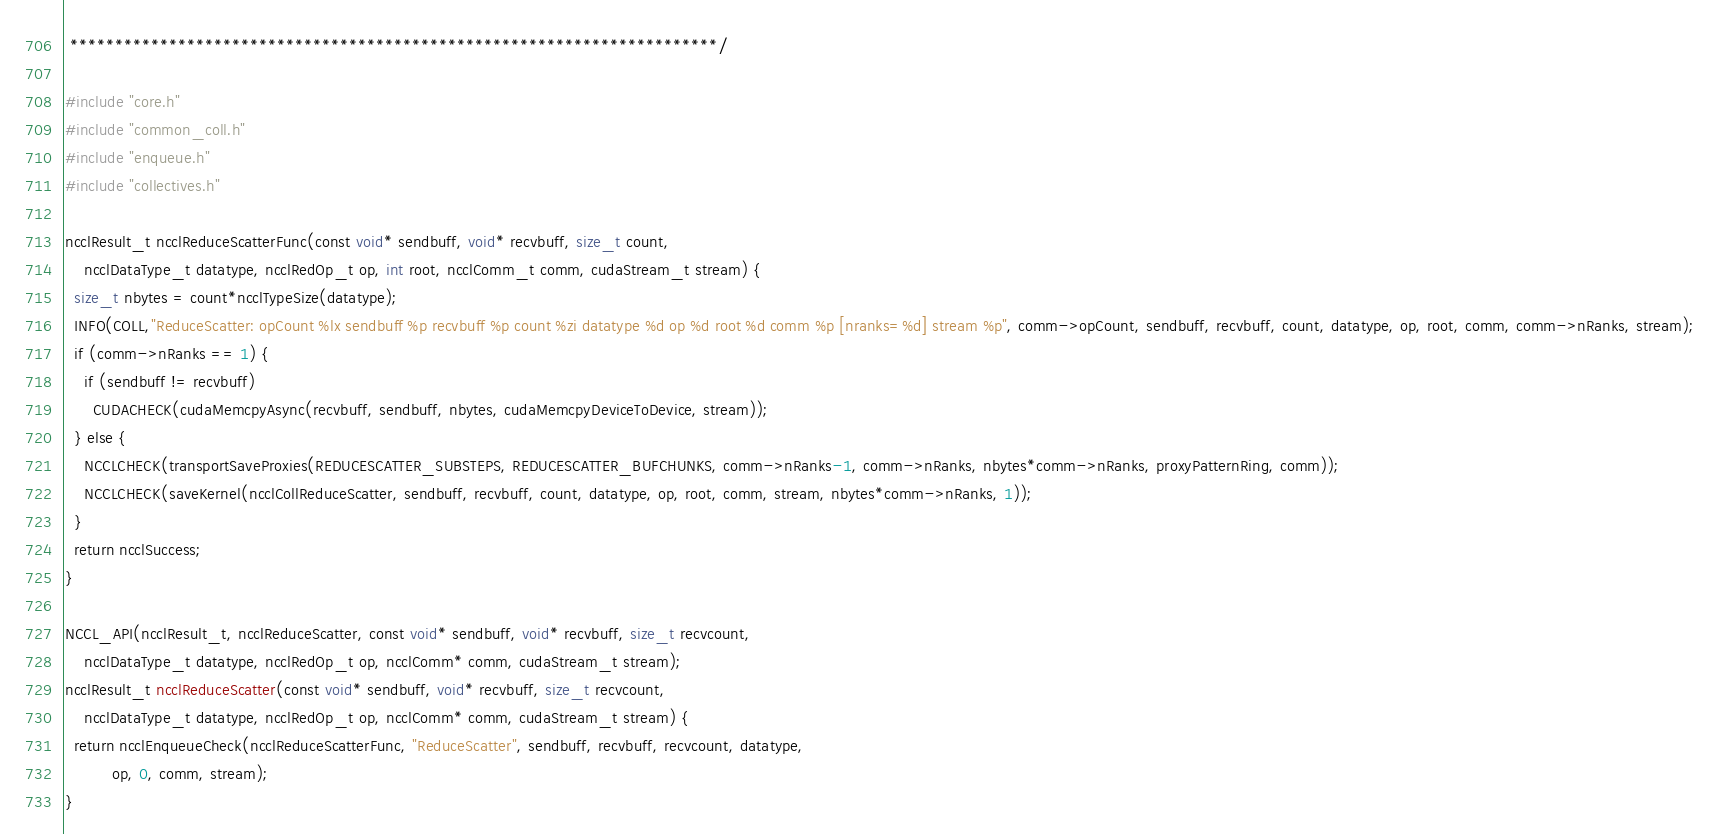<code> <loc_0><loc_0><loc_500><loc_500><_Cuda_> ************************************************************************/

#include "core.h"
#include "common_coll.h"
#include "enqueue.h"
#include "collectives.h"

ncclResult_t ncclReduceScatterFunc(const void* sendbuff, void* recvbuff, size_t count,
    ncclDataType_t datatype, ncclRedOp_t op, int root, ncclComm_t comm, cudaStream_t stream) {
  size_t nbytes = count*ncclTypeSize(datatype);
  INFO(COLL,"ReduceScatter: opCount %lx sendbuff %p recvbuff %p count %zi datatype %d op %d root %d comm %p [nranks=%d] stream %p", comm->opCount, sendbuff, recvbuff, count, datatype, op, root, comm, comm->nRanks, stream);
  if (comm->nRanks == 1) {
    if (sendbuff != recvbuff)
      CUDACHECK(cudaMemcpyAsync(recvbuff, sendbuff, nbytes, cudaMemcpyDeviceToDevice, stream));
  } else {
    NCCLCHECK(transportSaveProxies(REDUCESCATTER_SUBSTEPS, REDUCESCATTER_BUFCHUNKS, comm->nRanks-1, comm->nRanks, nbytes*comm->nRanks, proxyPatternRing, comm));
    NCCLCHECK(saveKernel(ncclCollReduceScatter, sendbuff, recvbuff, count, datatype, op, root, comm, stream, nbytes*comm->nRanks, 1));
  }
  return ncclSuccess;
}

NCCL_API(ncclResult_t, ncclReduceScatter, const void* sendbuff, void* recvbuff, size_t recvcount,
    ncclDataType_t datatype, ncclRedOp_t op, ncclComm* comm, cudaStream_t stream);
ncclResult_t ncclReduceScatter(const void* sendbuff, void* recvbuff, size_t recvcount,
    ncclDataType_t datatype, ncclRedOp_t op, ncclComm* comm, cudaStream_t stream) {
  return ncclEnqueueCheck(ncclReduceScatterFunc, "ReduceScatter", sendbuff, recvbuff, recvcount, datatype,
          op, 0, comm, stream);
}
</code> 